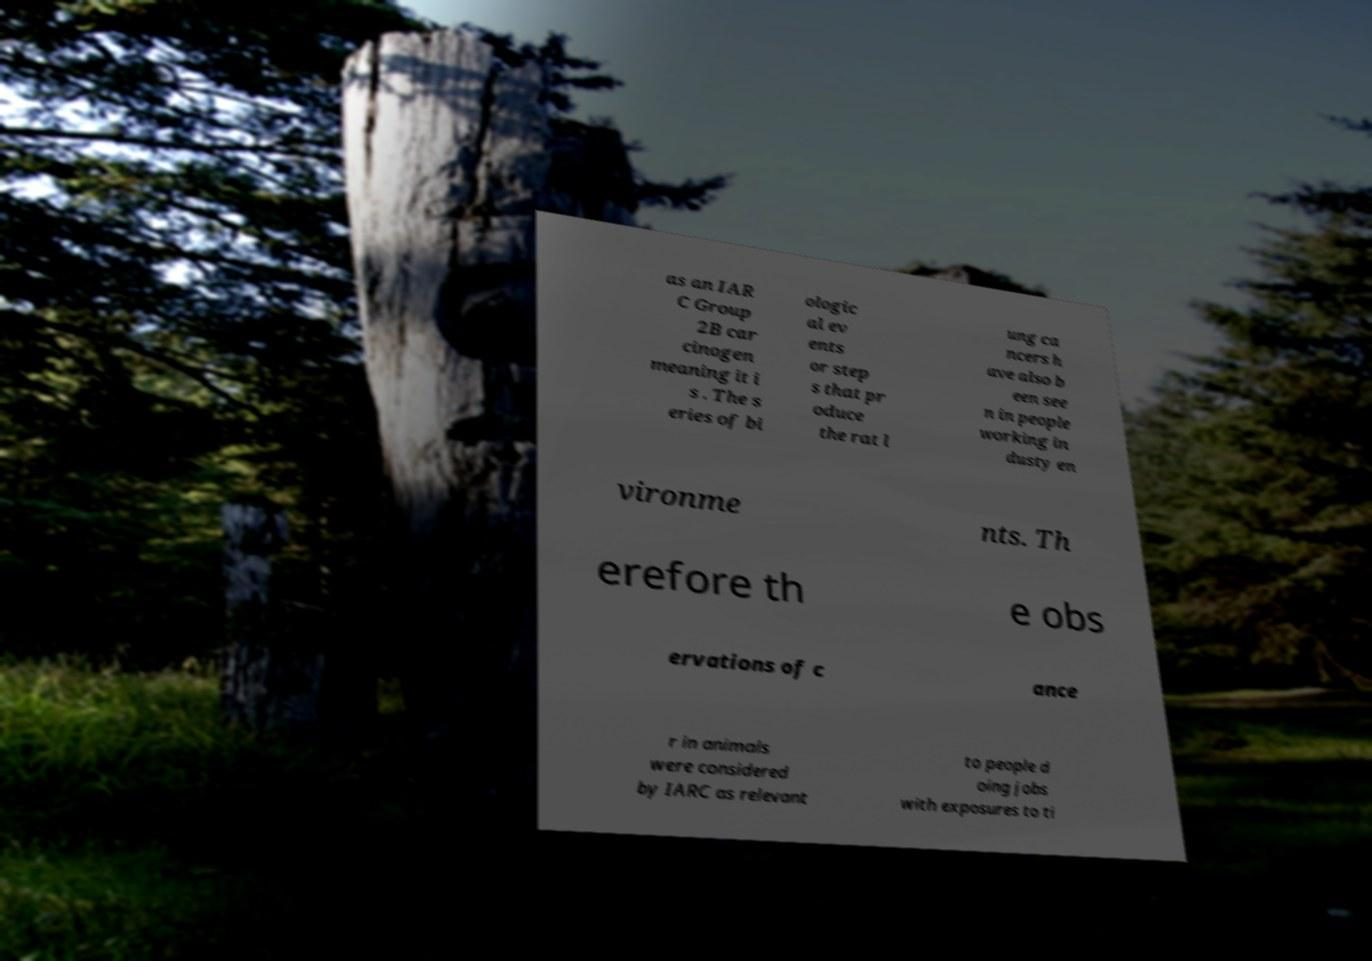Could you extract and type out the text from this image? as an IAR C Group 2B car cinogen meaning it i s . The s eries of bi ologic al ev ents or step s that pr oduce the rat l ung ca ncers h ave also b een see n in people working in dusty en vironme nts. Th erefore th e obs ervations of c ance r in animals were considered by IARC as relevant to people d oing jobs with exposures to ti 